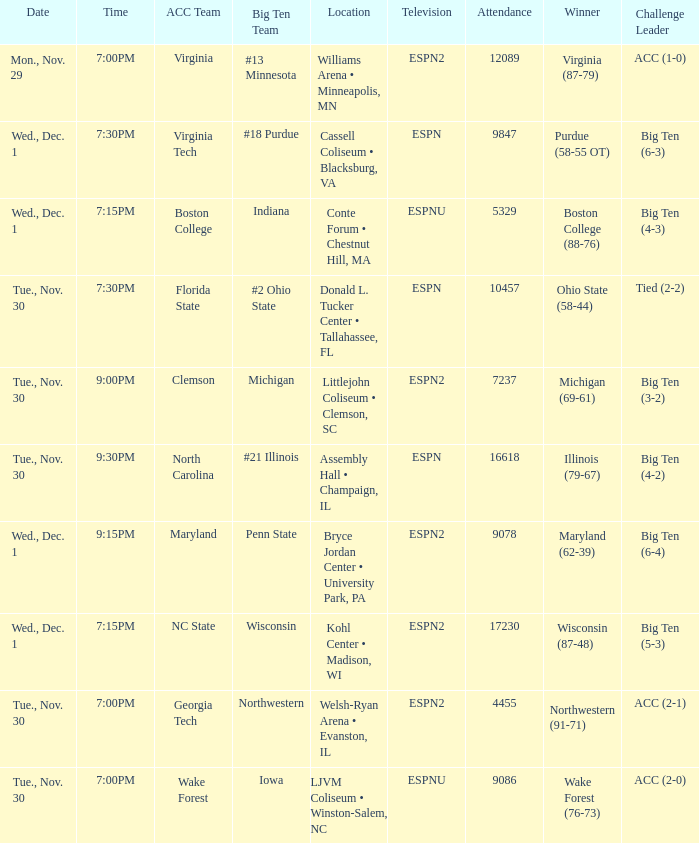Where did the games that had Wisconsin as big ten team take place? Kohl Center • Madison, WI. 